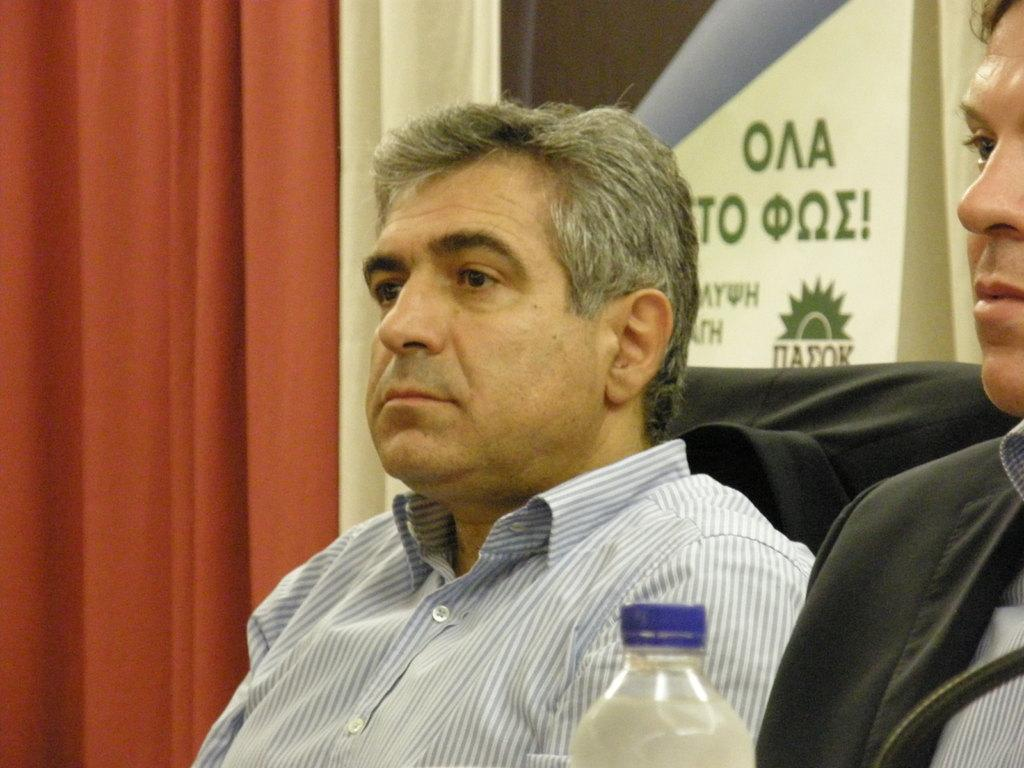How many people are sitting in the image? There are two men sitting in the image. What object can be seen at the bottom of the image? There is a bottle visible at the bottom of the image. What can be seen on the wall in the background of the image? There is a wall with text on it in the background of the image. What type of window treatment is visible in the background of the image? There are curtains visible in the background of the image. What type of skate is being used by one of the men in the image? There is no skate present in the image; both men are sitting. 